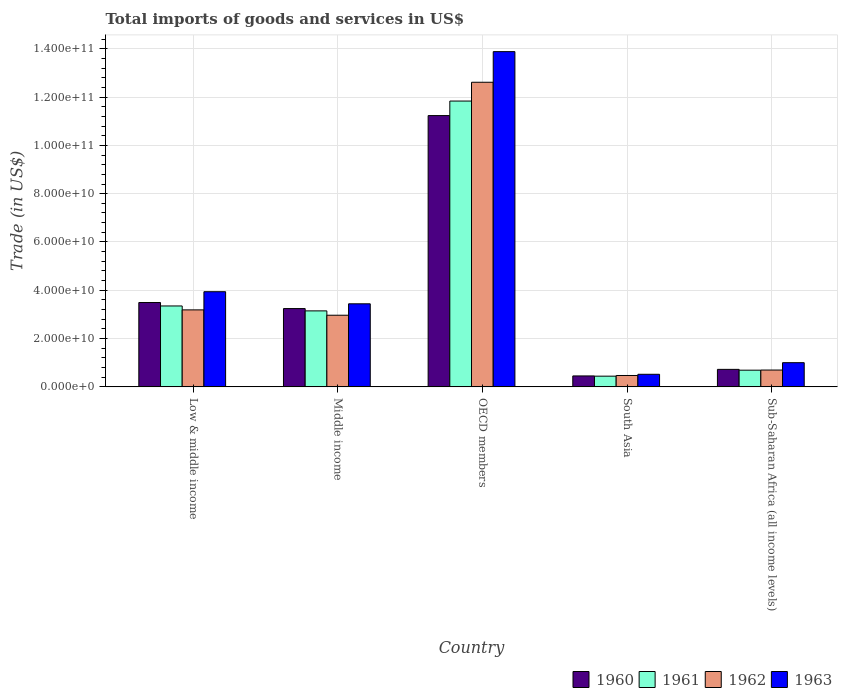How many different coloured bars are there?
Make the answer very short. 4. How many groups of bars are there?
Your answer should be very brief. 5. Are the number of bars per tick equal to the number of legend labels?
Your answer should be very brief. Yes. Are the number of bars on each tick of the X-axis equal?
Offer a very short reply. Yes. How many bars are there on the 3rd tick from the left?
Keep it short and to the point. 4. What is the label of the 5th group of bars from the left?
Provide a succinct answer. Sub-Saharan Africa (all income levels). In how many cases, is the number of bars for a given country not equal to the number of legend labels?
Keep it short and to the point. 0. What is the total imports of goods and services in 1960 in Middle income?
Offer a very short reply. 3.24e+1. Across all countries, what is the maximum total imports of goods and services in 1960?
Make the answer very short. 1.12e+11. Across all countries, what is the minimum total imports of goods and services in 1963?
Give a very brief answer. 5.21e+09. In which country was the total imports of goods and services in 1962 maximum?
Offer a terse response. OECD members. In which country was the total imports of goods and services in 1960 minimum?
Ensure brevity in your answer.  South Asia. What is the total total imports of goods and services in 1960 in the graph?
Your answer should be compact. 1.91e+11. What is the difference between the total imports of goods and services in 1963 in Low & middle income and that in Sub-Saharan Africa (all income levels)?
Your response must be concise. 2.94e+1. What is the difference between the total imports of goods and services in 1960 in Middle income and the total imports of goods and services in 1961 in OECD members?
Provide a succinct answer. -8.59e+1. What is the average total imports of goods and services in 1961 per country?
Offer a terse response. 3.89e+1. What is the difference between the total imports of goods and services of/in 1960 and total imports of goods and services of/in 1961 in South Asia?
Your answer should be compact. 9.31e+07. In how many countries, is the total imports of goods and services in 1961 greater than 44000000000 US$?
Give a very brief answer. 1. What is the ratio of the total imports of goods and services in 1960 in Middle income to that in OECD members?
Give a very brief answer. 0.29. Is the total imports of goods and services in 1960 in Low & middle income less than that in Middle income?
Ensure brevity in your answer.  No. Is the difference between the total imports of goods and services in 1960 in Middle income and OECD members greater than the difference between the total imports of goods and services in 1961 in Middle income and OECD members?
Offer a very short reply. Yes. What is the difference between the highest and the second highest total imports of goods and services in 1962?
Provide a short and direct response. 9.65e+1. What is the difference between the highest and the lowest total imports of goods and services in 1960?
Offer a terse response. 1.08e+11. Is the sum of the total imports of goods and services in 1963 in OECD members and South Asia greater than the maximum total imports of goods and services in 1962 across all countries?
Your answer should be compact. Yes. Is it the case that in every country, the sum of the total imports of goods and services in 1963 and total imports of goods and services in 1962 is greater than the sum of total imports of goods and services in 1961 and total imports of goods and services in 1960?
Provide a succinct answer. No. What does the 3rd bar from the left in OECD members represents?
Offer a very short reply. 1962. What does the 3rd bar from the right in OECD members represents?
Offer a terse response. 1961. How many bars are there?
Offer a very short reply. 20. Are all the bars in the graph horizontal?
Offer a terse response. No. Does the graph contain any zero values?
Offer a terse response. No. Does the graph contain grids?
Give a very brief answer. Yes. What is the title of the graph?
Your answer should be compact. Total imports of goods and services in US$. Does "1972" appear as one of the legend labels in the graph?
Offer a terse response. No. What is the label or title of the Y-axis?
Provide a short and direct response. Trade (in US$). What is the Trade (in US$) in 1960 in Low & middle income?
Provide a succinct answer. 3.49e+1. What is the Trade (in US$) of 1961 in Low & middle income?
Give a very brief answer. 3.35e+1. What is the Trade (in US$) of 1962 in Low & middle income?
Your response must be concise. 3.19e+1. What is the Trade (in US$) in 1963 in Low & middle income?
Ensure brevity in your answer.  3.94e+1. What is the Trade (in US$) of 1960 in Middle income?
Offer a very short reply. 3.24e+1. What is the Trade (in US$) of 1961 in Middle income?
Offer a terse response. 3.15e+1. What is the Trade (in US$) of 1962 in Middle income?
Make the answer very short. 2.97e+1. What is the Trade (in US$) in 1963 in Middle income?
Your response must be concise. 3.44e+1. What is the Trade (in US$) in 1960 in OECD members?
Offer a terse response. 1.12e+11. What is the Trade (in US$) of 1961 in OECD members?
Ensure brevity in your answer.  1.18e+11. What is the Trade (in US$) in 1962 in OECD members?
Your answer should be very brief. 1.26e+11. What is the Trade (in US$) of 1963 in OECD members?
Ensure brevity in your answer.  1.39e+11. What is the Trade (in US$) of 1960 in South Asia?
Provide a short and direct response. 4.53e+09. What is the Trade (in US$) in 1961 in South Asia?
Provide a short and direct response. 4.43e+09. What is the Trade (in US$) of 1962 in South Asia?
Keep it short and to the point. 4.71e+09. What is the Trade (in US$) in 1963 in South Asia?
Ensure brevity in your answer.  5.21e+09. What is the Trade (in US$) in 1960 in Sub-Saharan Africa (all income levels)?
Make the answer very short. 7.25e+09. What is the Trade (in US$) in 1961 in Sub-Saharan Africa (all income levels)?
Offer a terse response. 6.91e+09. What is the Trade (in US$) in 1962 in Sub-Saharan Africa (all income levels)?
Provide a succinct answer. 6.97e+09. What is the Trade (in US$) of 1963 in Sub-Saharan Africa (all income levels)?
Provide a succinct answer. 1.00e+1. Across all countries, what is the maximum Trade (in US$) of 1960?
Your response must be concise. 1.12e+11. Across all countries, what is the maximum Trade (in US$) in 1961?
Your answer should be compact. 1.18e+11. Across all countries, what is the maximum Trade (in US$) in 1962?
Provide a short and direct response. 1.26e+11. Across all countries, what is the maximum Trade (in US$) of 1963?
Ensure brevity in your answer.  1.39e+11. Across all countries, what is the minimum Trade (in US$) of 1960?
Your answer should be compact. 4.53e+09. Across all countries, what is the minimum Trade (in US$) of 1961?
Give a very brief answer. 4.43e+09. Across all countries, what is the minimum Trade (in US$) in 1962?
Offer a terse response. 4.71e+09. Across all countries, what is the minimum Trade (in US$) in 1963?
Offer a very short reply. 5.21e+09. What is the total Trade (in US$) of 1960 in the graph?
Your answer should be compact. 1.91e+11. What is the total Trade (in US$) in 1961 in the graph?
Your answer should be very brief. 1.95e+11. What is the total Trade (in US$) of 1962 in the graph?
Keep it short and to the point. 1.99e+11. What is the total Trade (in US$) in 1963 in the graph?
Your answer should be very brief. 2.28e+11. What is the difference between the Trade (in US$) in 1960 in Low & middle income and that in Middle income?
Your response must be concise. 2.50e+09. What is the difference between the Trade (in US$) of 1961 in Low & middle income and that in Middle income?
Your response must be concise. 2.04e+09. What is the difference between the Trade (in US$) of 1962 in Low & middle income and that in Middle income?
Offer a terse response. 2.21e+09. What is the difference between the Trade (in US$) of 1963 in Low & middle income and that in Middle income?
Your answer should be very brief. 5.01e+09. What is the difference between the Trade (in US$) of 1960 in Low & middle income and that in OECD members?
Provide a succinct answer. -7.74e+1. What is the difference between the Trade (in US$) in 1961 in Low & middle income and that in OECD members?
Your answer should be compact. -8.48e+1. What is the difference between the Trade (in US$) of 1962 in Low & middle income and that in OECD members?
Give a very brief answer. -9.43e+1. What is the difference between the Trade (in US$) of 1963 in Low & middle income and that in OECD members?
Provide a short and direct response. -9.94e+1. What is the difference between the Trade (in US$) in 1960 in Low & middle income and that in South Asia?
Your answer should be compact. 3.04e+1. What is the difference between the Trade (in US$) of 1961 in Low & middle income and that in South Asia?
Provide a succinct answer. 2.91e+1. What is the difference between the Trade (in US$) in 1962 in Low & middle income and that in South Asia?
Provide a succinct answer. 2.72e+1. What is the difference between the Trade (in US$) of 1963 in Low & middle income and that in South Asia?
Keep it short and to the point. 3.42e+1. What is the difference between the Trade (in US$) in 1960 in Low & middle income and that in Sub-Saharan Africa (all income levels)?
Keep it short and to the point. 2.77e+1. What is the difference between the Trade (in US$) in 1961 in Low & middle income and that in Sub-Saharan Africa (all income levels)?
Offer a very short reply. 2.66e+1. What is the difference between the Trade (in US$) of 1962 in Low & middle income and that in Sub-Saharan Africa (all income levels)?
Offer a very short reply. 2.49e+1. What is the difference between the Trade (in US$) of 1963 in Low & middle income and that in Sub-Saharan Africa (all income levels)?
Your answer should be very brief. 2.94e+1. What is the difference between the Trade (in US$) in 1960 in Middle income and that in OECD members?
Provide a succinct answer. -7.99e+1. What is the difference between the Trade (in US$) of 1961 in Middle income and that in OECD members?
Keep it short and to the point. -8.69e+1. What is the difference between the Trade (in US$) of 1962 in Middle income and that in OECD members?
Provide a short and direct response. -9.65e+1. What is the difference between the Trade (in US$) of 1963 in Middle income and that in OECD members?
Ensure brevity in your answer.  -1.04e+11. What is the difference between the Trade (in US$) of 1960 in Middle income and that in South Asia?
Your answer should be very brief. 2.79e+1. What is the difference between the Trade (in US$) in 1961 in Middle income and that in South Asia?
Give a very brief answer. 2.70e+1. What is the difference between the Trade (in US$) in 1962 in Middle income and that in South Asia?
Offer a terse response. 2.50e+1. What is the difference between the Trade (in US$) of 1963 in Middle income and that in South Asia?
Your response must be concise. 2.92e+1. What is the difference between the Trade (in US$) in 1960 in Middle income and that in Sub-Saharan Africa (all income levels)?
Your response must be concise. 2.52e+1. What is the difference between the Trade (in US$) of 1961 in Middle income and that in Sub-Saharan Africa (all income levels)?
Your answer should be very brief. 2.46e+1. What is the difference between the Trade (in US$) of 1962 in Middle income and that in Sub-Saharan Africa (all income levels)?
Your answer should be very brief. 2.27e+1. What is the difference between the Trade (in US$) of 1963 in Middle income and that in Sub-Saharan Africa (all income levels)?
Provide a succinct answer. 2.44e+1. What is the difference between the Trade (in US$) in 1960 in OECD members and that in South Asia?
Your answer should be compact. 1.08e+11. What is the difference between the Trade (in US$) of 1961 in OECD members and that in South Asia?
Make the answer very short. 1.14e+11. What is the difference between the Trade (in US$) of 1962 in OECD members and that in South Asia?
Give a very brief answer. 1.21e+11. What is the difference between the Trade (in US$) of 1963 in OECD members and that in South Asia?
Your answer should be compact. 1.34e+11. What is the difference between the Trade (in US$) of 1960 in OECD members and that in Sub-Saharan Africa (all income levels)?
Your answer should be compact. 1.05e+11. What is the difference between the Trade (in US$) of 1961 in OECD members and that in Sub-Saharan Africa (all income levels)?
Offer a terse response. 1.11e+11. What is the difference between the Trade (in US$) of 1962 in OECD members and that in Sub-Saharan Africa (all income levels)?
Your answer should be compact. 1.19e+11. What is the difference between the Trade (in US$) of 1963 in OECD members and that in Sub-Saharan Africa (all income levels)?
Provide a short and direct response. 1.29e+11. What is the difference between the Trade (in US$) in 1960 in South Asia and that in Sub-Saharan Africa (all income levels)?
Your response must be concise. -2.72e+09. What is the difference between the Trade (in US$) of 1961 in South Asia and that in Sub-Saharan Africa (all income levels)?
Your response must be concise. -2.47e+09. What is the difference between the Trade (in US$) of 1962 in South Asia and that in Sub-Saharan Africa (all income levels)?
Offer a very short reply. -2.26e+09. What is the difference between the Trade (in US$) in 1963 in South Asia and that in Sub-Saharan Africa (all income levels)?
Provide a short and direct response. -4.81e+09. What is the difference between the Trade (in US$) of 1960 in Low & middle income and the Trade (in US$) of 1961 in Middle income?
Your answer should be very brief. 3.46e+09. What is the difference between the Trade (in US$) of 1960 in Low & middle income and the Trade (in US$) of 1962 in Middle income?
Ensure brevity in your answer.  5.26e+09. What is the difference between the Trade (in US$) of 1960 in Low & middle income and the Trade (in US$) of 1963 in Middle income?
Your answer should be compact. 5.30e+08. What is the difference between the Trade (in US$) in 1961 in Low & middle income and the Trade (in US$) in 1962 in Middle income?
Your answer should be very brief. 3.84e+09. What is the difference between the Trade (in US$) of 1961 in Low & middle income and the Trade (in US$) of 1963 in Middle income?
Make the answer very short. -8.90e+08. What is the difference between the Trade (in US$) of 1962 in Low & middle income and the Trade (in US$) of 1963 in Middle income?
Your answer should be compact. -2.51e+09. What is the difference between the Trade (in US$) in 1960 in Low & middle income and the Trade (in US$) in 1961 in OECD members?
Keep it short and to the point. -8.34e+1. What is the difference between the Trade (in US$) of 1960 in Low & middle income and the Trade (in US$) of 1962 in OECD members?
Provide a succinct answer. -9.12e+1. What is the difference between the Trade (in US$) in 1960 in Low & middle income and the Trade (in US$) in 1963 in OECD members?
Provide a short and direct response. -1.04e+11. What is the difference between the Trade (in US$) of 1961 in Low & middle income and the Trade (in US$) of 1962 in OECD members?
Provide a short and direct response. -9.26e+1. What is the difference between the Trade (in US$) of 1961 in Low & middle income and the Trade (in US$) of 1963 in OECD members?
Offer a very short reply. -1.05e+11. What is the difference between the Trade (in US$) in 1962 in Low & middle income and the Trade (in US$) in 1963 in OECD members?
Keep it short and to the point. -1.07e+11. What is the difference between the Trade (in US$) in 1960 in Low & middle income and the Trade (in US$) in 1961 in South Asia?
Keep it short and to the point. 3.05e+1. What is the difference between the Trade (in US$) of 1960 in Low & middle income and the Trade (in US$) of 1962 in South Asia?
Your answer should be very brief. 3.02e+1. What is the difference between the Trade (in US$) in 1960 in Low & middle income and the Trade (in US$) in 1963 in South Asia?
Your answer should be very brief. 2.97e+1. What is the difference between the Trade (in US$) in 1961 in Low & middle income and the Trade (in US$) in 1962 in South Asia?
Provide a short and direct response. 2.88e+1. What is the difference between the Trade (in US$) of 1961 in Low & middle income and the Trade (in US$) of 1963 in South Asia?
Provide a succinct answer. 2.83e+1. What is the difference between the Trade (in US$) in 1962 in Low & middle income and the Trade (in US$) in 1963 in South Asia?
Your response must be concise. 2.67e+1. What is the difference between the Trade (in US$) in 1960 in Low & middle income and the Trade (in US$) in 1961 in Sub-Saharan Africa (all income levels)?
Make the answer very short. 2.80e+1. What is the difference between the Trade (in US$) of 1960 in Low & middle income and the Trade (in US$) of 1962 in Sub-Saharan Africa (all income levels)?
Provide a succinct answer. 2.80e+1. What is the difference between the Trade (in US$) of 1960 in Low & middle income and the Trade (in US$) of 1963 in Sub-Saharan Africa (all income levels)?
Offer a very short reply. 2.49e+1. What is the difference between the Trade (in US$) of 1961 in Low & middle income and the Trade (in US$) of 1962 in Sub-Saharan Africa (all income levels)?
Your response must be concise. 2.65e+1. What is the difference between the Trade (in US$) in 1961 in Low & middle income and the Trade (in US$) in 1963 in Sub-Saharan Africa (all income levels)?
Your answer should be compact. 2.35e+1. What is the difference between the Trade (in US$) of 1962 in Low & middle income and the Trade (in US$) of 1963 in Sub-Saharan Africa (all income levels)?
Keep it short and to the point. 2.19e+1. What is the difference between the Trade (in US$) of 1960 in Middle income and the Trade (in US$) of 1961 in OECD members?
Keep it short and to the point. -8.59e+1. What is the difference between the Trade (in US$) in 1960 in Middle income and the Trade (in US$) in 1962 in OECD members?
Offer a very short reply. -9.37e+1. What is the difference between the Trade (in US$) of 1960 in Middle income and the Trade (in US$) of 1963 in OECD members?
Make the answer very short. -1.06e+11. What is the difference between the Trade (in US$) in 1961 in Middle income and the Trade (in US$) in 1962 in OECD members?
Offer a very short reply. -9.47e+1. What is the difference between the Trade (in US$) in 1961 in Middle income and the Trade (in US$) in 1963 in OECD members?
Offer a very short reply. -1.07e+11. What is the difference between the Trade (in US$) of 1962 in Middle income and the Trade (in US$) of 1963 in OECD members?
Your answer should be very brief. -1.09e+11. What is the difference between the Trade (in US$) in 1960 in Middle income and the Trade (in US$) in 1961 in South Asia?
Your answer should be compact. 2.80e+1. What is the difference between the Trade (in US$) of 1960 in Middle income and the Trade (in US$) of 1962 in South Asia?
Make the answer very short. 2.77e+1. What is the difference between the Trade (in US$) of 1960 in Middle income and the Trade (in US$) of 1963 in South Asia?
Your answer should be compact. 2.72e+1. What is the difference between the Trade (in US$) in 1961 in Middle income and the Trade (in US$) in 1962 in South Asia?
Offer a terse response. 2.68e+1. What is the difference between the Trade (in US$) of 1961 in Middle income and the Trade (in US$) of 1963 in South Asia?
Offer a terse response. 2.63e+1. What is the difference between the Trade (in US$) in 1962 in Middle income and the Trade (in US$) in 1963 in South Asia?
Offer a terse response. 2.45e+1. What is the difference between the Trade (in US$) of 1960 in Middle income and the Trade (in US$) of 1961 in Sub-Saharan Africa (all income levels)?
Your answer should be compact. 2.55e+1. What is the difference between the Trade (in US$) in 1960 in Middle income and the Trade (in US$) in 1962 in Sub-Saharan Africa (all income levels)?
Offer a very short reply. 2.55e+1. What is the difference between the Trade (in US$) in 1960 in Middle income and the Trade (in US$) in 1963 in Sub-Saharan Africa (all income levels)?
Provide a short and direct response. 2.24e+1. What is the difference between the Trade (in US$) in 1961 in Middle income and the Trade (in US$) in 1962 in Sub-Saharan Africa (all income levels)?
Ensure brevity in your answer.  2.45e+1. What is the difference between the Trade (in US$) of 1961 in Middle income and the Trade (in US$) of 1963 in Sub-Saharan Africa (all income levels)?
Offer a terse response. 2.14e+1. What is the difference between the Trade (in US$) of 1962 in Middle income and the Trade (in US$) of 1963 in Sub-Saharan Africa (all income levels)?
Ensure brevity in your answer.  1.96e+1. What is the difference between the Trade (in US$) of 1960 in OECD members and the Trade (in US$) of 1961 in South Asia?
Provide a short and direct response. 1.08e+11. What is the difference between the Trade (in US$) in 1960 in OECD members and the Trade (in US$) in 1962 in South Asia?
Offer a very short reply. 1.08e+11. What is the difference between the Trade (in US$) of 1960 in OECD members and the Trade (in US$) of 1963 in South Asia?
Your response must be concise. 1.07e+11. What is the difference between the Trade (in US$) of 1961 in OECD members and the Trade (in US$) of 1962 in South Asia?
Your answer should be very brief. 1.14e+11. What is the difference between the Trade (in US$) in 1961 in OECD members and the Trade (in US$) in 1963 in South Asia?
Your response must be concise. 1.13e+11. What is the difference between the Trade (in US$) of 1962 in OECD members and the Trade (in US$) of 1963 in South Asia?
Your answer should be very brief. 1.21e+11. What is the difference between the Trade (in US$) in 1960 in OECD members and the Trade (in US$) in 1961 in Sub-Saharan Africa (all income levels)?
Give a very brief answer. 1.05e+11. What is the difference between the Trade (in US$) in 1960 in OECD members and the Trade (in US$) in 1962 in Sub-Saharan Africa (all income levels)?
Your answer should be very brief. 1.05e+11. What is the difference between the Trade (in US$) in 1960 in OECD members and the Trade (in US$) in 1963 in Sub-Saharan Africa (all income levels)?
Give a very brief answer. 1.02e+11. What is the difference between the Trade (in US$) in 1961 in OECD members and the Trade (in US$) in 1962 in Sub-Saharan Africa (all income levels)?
Ensure brevity in your answer.  1.11e+11. What is the difference between the Trade (in US$) in 1961 in OECD members and the Trade (in US$) in 1963 in Sub-Saharan Africa (all income levels)?
Your response must be concise. 1.08e+11. What is the difference between the Trade (in US$) of 1962 in OECD members and the Trade (in US$) of 1963 in Sub-Saharan Africa (all income levels)?
Make the answer very short. 1.16e+11. What is the difference between the Trade (in US$) of 1960 in South Asia and the Trade (in US$) of 1961 in Sub-Saharan Africa (all income levels)?
Your response must be concise. -2.38e+09. What is the difference between the Trade (in US$) in 1960 in South Asia and the Trade (in US$) in 1962 in Sub-Saharan Africa (all income levels)?
Give a very brief answer. -2.44e+09. What is the difference between the Trade (in US$) of 1960 in South Asia and the Trade (in US$) of 1963 in Sub-Saharan Africa (all income levels)?
Ensure brevity in your answer.  -5.49e+09. What is the difference between the Trade (in US$) in 1961 in South Asia and the Trade (in US$) in 1962 in Sub-Saharan Africa (all income levels)?
Offer a very short reply. -2.53e+09. What is the difference between the Trade (in US$) of 1961 in South Asia and the Trade (in US$) of 1963 in Sub-Saharan Africa (all income levels)?
Provide a short and direct response. -5.58e+09. What is the difference between the Trade (in US$) in 1962 in South Asia and the Trade (in US$) in 1963 in Sub-Saharan Africa (all income levels)?
Give a very brief answer. -5.31e+09. What is the average Trade (in US$) of 1960 per country?
Offer a very short reply. 3.83e+1. What is the average Trade (in US$) of 1961 per country?
Your response must be concise. 3.89e+1. What is the average Trade (in US$) in 1962 per country?
Provide a short and direct response. 3.99e+1. What is the average Trade (in US$) of 1963 per country?
Offer a very short reply. 4.56e+1. What is the difference between the Trade (in US$) of 1960 and Trade (in US$) of 1961 in Low & middle income?
Give a very brief answer. 1.42e+09. What is the difference between the Trade (in US$) in 1960 and Trade (in US$) in 1962 in Low & middle income?
Provide a succinct answer. 3.05e+09. What is the difference between the Trade (in US$) of 1960 and Trade (in US$) of 1963 in Low & middle income?
Provide a succinct answer. -4.48e+09. What is the difference between the Trade (in US$) in 1961 and Trade (in US$) in 1962 in Low & middle income?
Provide a succinct answer. 1.62e+09. What is the difference between the Trade (in US$) in 1961 and Trade (in US$) in 1963 in Low & middle income?
Provide a succinct answer. -5.90e+09. What is the difference between the Trade (in US$) in 1962 and Trade (in US$) in 1963 in Low & middle income?
Make the answer very short. -7.52e+09. What is the difference between the Trade (in US$) of 1960 and Trade (in US$) of 1961 in Middle income?
Your answer should be very brief. 9.57e+08. What is the difference between the Trade (in US$) of 1960 and Trade (in US$) of 1962 in Middle income?
Your answer should be compact. 2.76e+09. What is the difference between the Trade (in US$) in 1960 and Trade (in US$) in 1963 in Middle income?
Ensure brevity in your answer.  -1.97e+09. What is the difference between the Trade (in US$) in 1961 and Trade (in US$) in 1962 in Middle income?
Keep it short and to the point. 1.80e+09. What is the difference between the Trade (in US$) of 1961 and Trade (in US$) of 1963 in Middle income?
Your answer should be very brief. -2.93e+09. What is the difference between the Trade (in US$) of 1962 and Trade (in US$) of 1963 in Middle income?
Provide a succinct answer. -4.73e+09. What is the difference between the Trade (in US$) of 1960 and Trade (in US$) of 1961 in OECD members?
Ensure brevity in your answer.  -6.01e+09. What is the difference between the Trade (in US$) in 1960 and Trade (in US$) in 1962 in OECD members?
Your answer should be compact. -1.38e+1. What is the difference between the Trade (in US$) of 1960 and Trade (in US$) of 1963 in OECD members?
Offer a terse response. -2.65e+1. What is the difference between the Trade (in US$) in 1961 and Trade (in US$) in 1962 in OECD members?
Offer a terse response. -7.79e+09. What is the difference between the Trade (in US$) in 1961 and Trade (in US$) in 1963 in OECD members?
Keep it short and to the point. -2.05e+1. What is the difference between the Trade (in US$) of 1962 and Trade (in US$) of 1963 in OECD members?
Keep it short and to the point. -1.27e+1. What is the difference between the Trade (in US$) in 1960 and Trade (in US$) in 1961 in South Asia?
Keep it short and to the point. 9.31e+07. What is the difference between the Trade (in US$) in 1960 and Trade (in US$) in 1962 in South Asia?
Your answer should be compact. -1.84e+08. What is the difference between the Trade (in US$) of 1960 and Trade (in US$) of 1963 in South Asia?
Your response must be concise. -6.84e+08. What is the difference between the Trade (in US$) of 1961 and Trade (in US$) of 1962 in South Asia?
Keep it short and to the point. -2.77e+08. What is the difference between the Trade (in US$) in 1961 and Trade (in US$) in 1963 in South Asia?
Provide a short and direct response. -7.77e+08. What is the difference between the Trade (in US$) of 1962 and Trade (in US$) of 1963 in South Asia?
Offer a terse response. -5.00e+08. What is the difference between the Trade (in US$) of 1960 and Trade (in US$) of 1961 in Sub-Saharan Africa (all income levels)?
Provide a succinct answer. 3.36e+08. What is the difference between the Trade (in US$) of 1960 and Trade (in US$) of 1962 in Sub-Saharan Africa (all income levels)?
Give a very brief answer. 2.78e+08. What is the difference between the Trade (in US$) in 1960 and Trade (in US$) in 1963 in Sub-Saharan Africa (all income levels)?
Offer a very short reply. -2.77e+09. What is the difference between the Trade (in US$) in 1961 and Trade (in US$) in 1962 in Sub-Saharan Africa (all income levels)?
Your answer should be compact. -5.80e+07. What is the difference between the Trade (in US$) of 1961 and Trade (in US$) of 1963 in Sub-Saharan Africa (all income levels)?
Make the answer very short. -3.11e+09. What is the difference between the Trade (in US$) of 1962 and Trade (in US$) of 1963 in Sub-Saharan Africa (all income levels)?
Offer a terse response. -3.05e+09. What is the ratio of the Trade (in US$) of 1960 in Low & middle income to that in Middle income?
Provide a succinct answer. 1.08. What is the ratio of the Trade (in US$) of 1961 in Low & middle income to that in Middle income?
Offer a very short reply. 1.06. What is the ratio of the Trade (in US$) of 1962 in Low & middle income to that in Middle income?
Ensure brevity in your answer.  1.07. What is the ratio of the Trade (in US$) in 1963 in Low & middle income to that in Middle income?
Ensure brevity in your answer.  1.15. What is the ratio of the Trade (in US$) in 1960 in Low & middle income to that in OECD members?
Your response must be concise. 0.31. What is the ratio of the Trade (in US$) in 1961 in Low & middle income to that in OECD members?
Offer a very short reply. 0.28. What is the ratio of the Trade (in US$) in 1962 in Low & middle income to that in OECD members?
Give a very brief answer. 0.25. What is the ratio of the Trade (in US$) in 1963 in Low & middle income to that in OECD members?
Your response must be concise. 0.28. What is the ratio of the Trade (in US$) of 1960 in Low & middle income to that in South Asia?
Provide a short and direct response. 7.71. What is the ratio of the Trade (in US$) of 1961 in Low & middle income to that in South Asia?
Offer a terse response. 7.55. What is the ratio of the Trade (in US$) of 1962 in Low & middle income to that in South Asia?
Your response must be concise. 6.77. What is the ratio of the Trade (in US$) in 1963 in Low & middle income to that in South Asia?
Ensure brevity in your answer.  7.56. What is the ratio of the Trade (in US$) in 1960 in Low & middle income to that in Sub-Saharan Africa (all income levels)?
Your answer should be very brief. 4.82. What is the ratio of the Trade (in US$) in 1961 in Low & middle income to that in Sub-Saharan Africa (all income levels)?
Your response must be concise. 4.85. What is the ratio of the Trade (in US$) in 1962 in Low & middle income to that in Sub-Saharan Africa (all income levels)?
Make the answer very short. 4.58. What is the ratio of the Trade (in US$) of 1963 in Low & middle income to that in Sub-Saharan Africa (all income levels)?
Give a very brief answer. 3.93. What is the ratio of the Trade (in US$) in 1960 in Middle income to that in OECD members?
Ensure brevity in your answer.  0.29. What is the ratio of the Trade (in US$) in 1961 in Middle income to that in OECD members?
Ensure brevity in your answer.  0.27. What is the ratio of the Trade (in US$) of 1962 in Middle income to that in OECD members?
Offer a very short reply. 0.24. What is the ratio of the Trade (in US$) in 1963 in Middle income to that in OECD members?
Give a very brief answer. 0.25. What is the ratio of the Trade (in US$) in 1960 in Middle income to that in South Asia?
Your answer should be compact. 7.16. What is the ratio of the Trade (in US$) of 1961 in Middle income to that in South Asia?
Give a very brief answer. 7.1. What is the ratio of the Trade (in US$) of 1962 in Middle income to that in South Asia?
Provide a succinct answer. 6.3. What is the ratio of the Trade (in US$) in 1963 in Middle income to that in South Asia?
Offer a very short reply. 6.6. What is the ratio of the Trade (in US$) of 1960 in Middle income to that in Sub-Saharan Africa (all income levels)?
Keep it short and to the point. 4.47. What is the ratio of the Trade (in US$) in 1961 in Middle income to that in Sub-Saharan Africa (all income levels)?
Provide a short and direct response. 4.55. What is the ratio of the Trade (in US$) in 1962 in Middle income to that in Sub-Saharan Africa (all income levels)?
Provide a succinct answer. 4.26. What is the ratio of the Trade (in US$) of 1963 in Middle income to that in Sub-Saharan Africa (all income levels)?
Ensure brevity in your answer.  3.43. What is the ratio of the Trade (in US$) in 1960 in OECD members to that in South Asia?
Offer a very short reply. 24.81. What is the ratio of the Trade (in US$) of 1961 in OECD members to that in South Asia?
Give a very brief answer. 26.69. What is the ratio of the Trade (in US$) of 1962 in OECD members to that in South Asia?
Your answer should be compact. 26.77. What is the ratio of the Trade (in US$) of 1963 in OECD members to that in South Asia?
Provide a succinct answer. 26.63. What is the ratio of the Trade (in US$) of 1960 in OECD members to that in Sub-Saharan Africa (all income levels)?
Give a very brief answer. 15.5. What is the ratio of the Trade (in US$) of 1961 in OECD members to that in Sub-Saharan Africa (all income levels)?
Make the answer very short. 17.13. What is the ratio of the Trade (in US$) in 1962 in OECD members to that in Sub-Saharan Africa (all income levels)?
Offer a terse response. 18.1. What is the ratio of the Trade (in US$) in 1963 in OECD members to that in Sub-Saharan Africa (all income levels)?
Give a very brief answer. 13.86. What is the ratio of the Trade (in US$) of 1960 in South Asia to that in Sub-Saharan Africa (all income levels)?
Ensure brevity in your answer.  0.62. What is the ratio of the Trade (in US$) of 1961 in South Asia to that in Sub-Saharan Africa (all income levels)?
Offer a terse response. 0.64. What is the ratio of the Trade (in US$) of 1962 in South Asia to that in Sub-Saharan Africa (all income levels)?
Your response must be concise. 0.68. What is the ratio of the Trade (in US$) in 1963 in South Asia to that in Sub-Saharan Africa (all income levels)?
Provide a short and direct response. 0.52. What is the difference between the highest and the second highest Trade (in US$) in 1960?
Your answer should be very brief. 7.74e+1. What is the difference between the highest and the second highest Trade (in US$) in 1961?
Your response must be concise. 8.48e+1. What is the difference between the highest and the second highest Trade (in US$) in 1962?
Your answer should be very brief. 9.43e+1. What is the difference between the highest and the second highest Trade (in US$) in 1963?
Provide a short and direct response. 9.94e+1. What is the difference between the highest and the lowest Trade (in US$) of 1960?
Provide a short and direct response. 1.08e+11. What is the difference between the highest and the lowest Trade (in US$) in 1961?
Your answer should be compact. 1.14e+11. What is the difference between the highest and the lowest Trade (in US$) in 1962?
Offer a very short reply. 1.21e+11. What is the difference between the highest and the lowest Trade (in US$) in 1963?
Your answer should be very brief. 1.34e+11. 